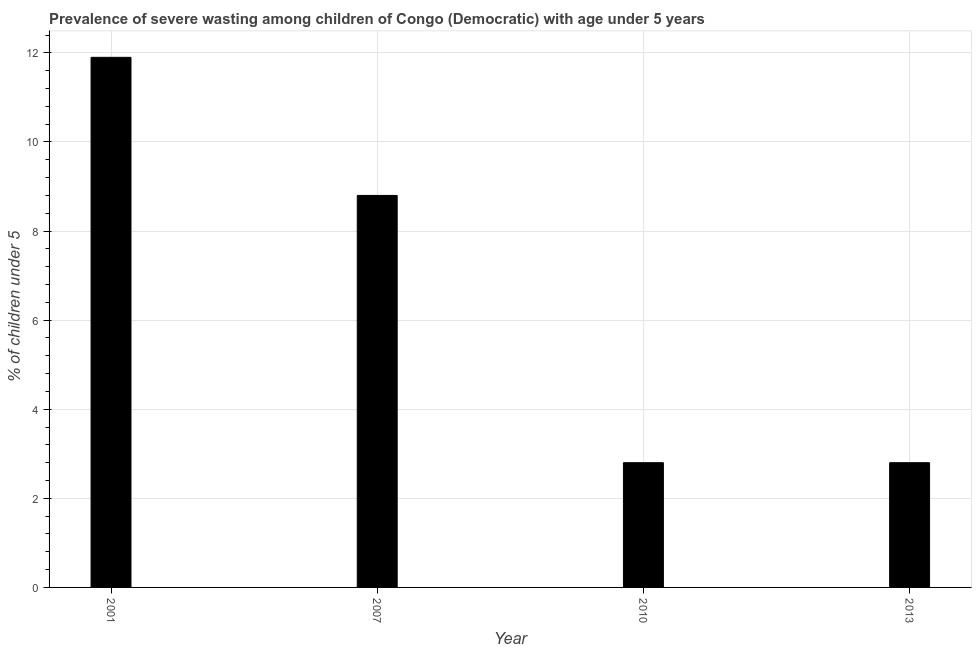Does the graph contain grids?
Offer a very short reply. Yes. What is the title of the graph?
Provide a short and direct response. Prevalence of severe wasting among children of Congo (Democratic) with age under 5 years. What is the label or title of the X-axis?
Offer a very short reply. Year. What is the label or title of the Y-axis?
Keep it short and to the point.  % of children under 5. What is the prevalence of severe wasting in 2013?
Offer a terse response. 2.8. Across all years, what is the maximum prevalence of severe wasting?
Make the answer very short. 11.9. Across all years, what is the minimum prevalence of severe wasting?
Provide a succinct answer. 2.8. In which year was the prevalence of severe wasting maximum?
Your response must be concise. 2001. What is the sum of the prevalence of severe wasting?
Give a very brief answer. 26.3. What is the difference between the prevalence of severe wasting in 2010 and 2013?
Provide a succinct answer. 0. What is the average prevalence of severe wasting per year?
Your response must be concise. 6.58. What is the median prevalence of severe wasting?
Keep it short and to the point. 5.8. In how many years, is the prevalence of severe wasting greater than 9.2 %?
Give a very brief answer. 1. Do a majority of the years between 2001 and 2013 (inclusive) have prevalence of severe wasting greater than 2.8 %?
Your response must be concise. No. What is the ratio of the prevalence of severe wasting in 2007 to that in 2010?
Provide a short and direct response. 3.14. Is the difference between the prevalence of severe wasting in 2001 and 2010 greater than the difference between any two years?
Your response must be concise. Yes. In how many years, is the prevalence of severe wasting greater than the average prevalence of severe wasting taken over all years?
Your answer should be compact. 2. How many bars are there?
Offer a very short reply. 4. Are all the bars in the graph horizontal?
Give a very brief answer. No. What is the difference between two consecutive major ticks on the Y-axis?
Keep it short and to the point. 2. Are the values on the major ticks of Y-axis written in scientific E-notation?
Give a very brief answer. No. What is the  % of children under 5 of 2001?
Your answer should be compact. 11.9. What is the  % of children under 5 in 2007?
Make the answer very short. 8.8. What is the  % of children under 5 in 2010?
Provide a succinct answer. 2.8. What is the  % of children under 5 of 2013?
Your response must be concise. 2.8. What is the difference between the  % of children under 5 in 2001 and 2007?
Provide a short and direct response. 3.1. What is the difference between the  % of children under 5 in 2007 and 2010?
Your answer should be very brief. 6. What is the difference between the  % of children under 5 in 2010 and 2013?
Make the answer very short. 0. What is the ratio of the  % of children under 5 in 2001 to that in 2007?
Your answer should be very brief. 1.35. What is the ratio of the  % of children under 5 in 2001 to that in 2010?
Ensure brevity in your answer.  4.25. What is the ratio of the  % of children under 5 in 2001 to that in 2013?
Provide a short and direct response. 4.25. What is the ratio of the  % of children under 5 in 2007 to that in 2010?
Provide a succinct answer. 3.14. What is the ratio of the  % of children under 5 in 2007 to that in 2013?
Your answer should be compact. 3.14. 